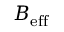Convert formula to latex. <formula><loc_0><loc_0><loc_500><loc_500>B _ { e f f }</formula> 